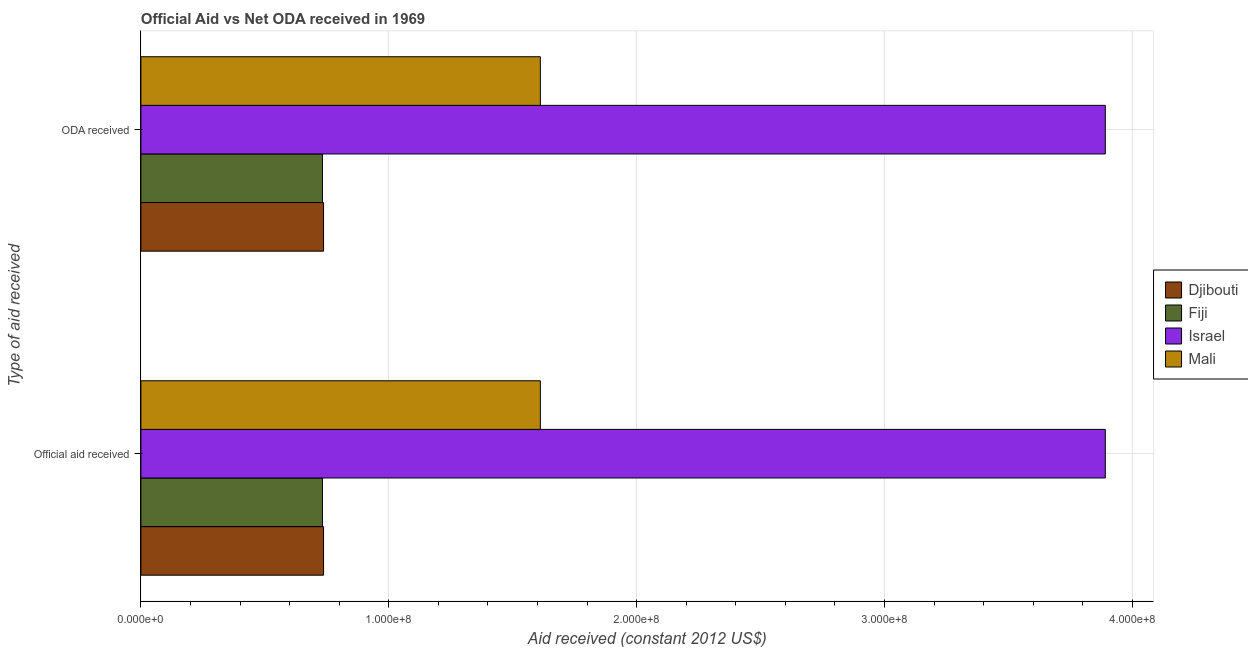How many different coloured bars are there?
Your answer should be very brief. 4. How many groups of bars are there?
Your answer should be compact. 2. How many bars are there on the 2nd tick from the top?
Your response must be concise. 4. How many bars are there on the 1st tick from the bottom?
Provide a succinct answer. 4. What is the label of the 1st group of bars from the top?
Provide a succinct answer. ODA received. What is the oda received in Israel?
Offer a very short reply. 3.89e+08. Across all countries, what is the maximum official aid received?
Ensure brevity in your answer.  3.89e+08. Across all countries, what is the minimum oda received?
Ensure brevity in your answer.  7.32e+07. In which country was the official aid received maximum?
Make the answer very short. Israel. In which country was the official aid received minimum?
Ensure brevity in your answer.  Fiji. What is the total official aid received in the graph?
Give a very brief answer. 6.97e+08. What is the difference between the official aid received in Israel and that in Djibouti?
Your answer should be compact. 3.15e+08. What is the difference between the oda received in Mali and the official aid received in Fiji?
Your answer should be compact. 8.79e+07. What is the average oda received per country?
Ensure brevity in your answer.  1.74e+08. What is the difference between the official aid received and oda received in Israel?
Provide a succinct answer. 0. What is the ratio of the official aid received in Mali to that in Israel?
Your answer should be very brief. 0.41. What does the 1st bar from the top in ODA received represents?
Provide a succinct answer. Mali. What does the 3rd bar from the bottom in ODA received represents?
Your answer should be very brief. Israel. How many bars are there?
Offer a very short reply. 8. Are all the bars in the graph horizontal?
Give a very brief answer. Yes. How many countries are there in the graph?
Provide a short and direct response. 4. Are the values on the major ticks of X-axis written in scientific E-notation?
Make the answer very short. Yes. Does the graph contain grids?
Give a very brief answer. Yes. Where does the legend appear in the graph?
Offer a terse response. Center right. How many legend labels are there?
Offer a very short reply. 4. How are the legend labels stacked?
Ensure brevity in your answer.  Vertical. What is the title of the graph?
Keep it short and to the point. Official Aid vs Net ODA received in 1969 . Does "Bhutan" appear as one of the legend labels in the graph?
Your response must be concise. No. What is the label or title of the X-axis?
Keep it short and to the point. Aid received (constant 2012 US$). What is the label or title of the Y-axis?
Provide a succinct answer. Type of aid received. What is the Aid received (constant 2012 US$) in Djibouti in Official aid received?
Offer a very short reply. 7.37e+07. What is the Aid received (constant 2012 US$) of Fiji in Official aid received?
Offer a terse response. 7.32e+07. What is the Aid received (constant 2012 US$) in Israel in Official aid received?
Your response must be concise. 3.89e+08. What is the Aid received (constant 2012 US$) in Mali in Official aid received?
Provide a short and direct response. 1.61e+08. What is the Aid received (constant 2012 US$) of Djibouti in ODA received?
Ensure brevity in your answer.  7.37e+07. What is the Aid received (constant 2012 US$) of Fiji in ODA received?
Keep it short and to the point. 7.32e+07. What is the Aid received (constant 2012 US$) of Israel in ODA received?
Your answer should be compact. 3.89e+08. What is the Aid received (constant 2012 US$) in Mali in ODA received?
Ensure brevity in your answer.  1.61e+08. Across all Type of aid received, what is the maximum Aid received (constant 2012 US$) of Djibouti?
Your answer should be compact. 7.37e+07. Across all Type of aid received, what is the maximum Aid received (constant 2012 US$) of Fiji?
Your answer should be very brief. 7.32e+07. Across all Type of aid received, what is the maximum Aid received (constant 2012 US$) in Israel?
Offer a very short reply. 3.89e+08. Across all Type of aid received, what is the maximum Aid received (constant 2012 US$) of Mali?
Make the answer very short. 1.61e+08. Across all Type of aid received, what is the minimum Aid received (constant 2012 US$) of Djibouti?
Your answer should be very brief. 7.37e+07. Across all Type of aid received, what is the minimum Aid received (constant 2012 US$) of Fiji?
Ensure brevity in your answer.  7.32e+07. Across all Type of aid received, what is the minimum Aid received (constant 2012 US$) of Israel?
Ensure brevity in your answer.  3.89e+08. Across all Type of aid received, what is the minimum Aid received (constant 2012 US$) in Mali?
Give a very brief answer. 1.61e+08. What is the total Aid received (constant 2012 US$) in Djibouti in the graph?
Keep it short and to the point. 1.47e+08. What is the total Aid received (constant 2012 US$) in Fiji in the graph?
Make the answer very short. 1.46e+08. What is the total Aid received (constant 2012 US$) of Israel in the graph?
Give a very brief answer. 7.78e+08. What is the total Aid received (constant 2012 US$) of Mali in the graph?
Make the answer very short. 3.22e+08. What is the difference between the Aid received (constant 2012 US$) of Fiji in Official aid received and that in ODA received?
Offer a terse response. 0. What is the difference between the Aid received (constant 2012 US$) in Israel in Official aid received and that in ODA received?
Provide a short and direct response. 0. What is the difference between the Aid received (constant 2012 US$) in Mali in Official aid received and that in ODA received?
Ensure brevity in your answer.  0. What is the difference between the Aid received (constant 2012 US$) of Djibouti in Official aid received and the Aid received (constant 2012 US$) of Israel in ODA received?
Offer a terse response. -3.15e+08. What is the difference between the Aid received (constant 2012 US$) of Djibouti in Official aid received and the Aid received (constant 2012 US$) of Mali in ODA received?
Make the answer very short. -8.74e+07. What is the difference between the Aid received (constant 2012 US$) in Fiji in Official aid received and the Aid received (constant 2012 US$) in Israel in ODA received?
Ensure brevity in your answer.  -3.16e+08. What is the difference between the Aid received (constant 2012 US$) of Fiji in Official aid received and the Aid received (constant 2012 US$) of Mali in ODA received?
Your response must be concise. -8.79e+07. What is the difference between the Aid received (constant 2012 US$) of Israel in Official aid received and the Aid received (constant 2012 US$) of Mali in ODA received?
Keep it short and to the point. 2.28e+08. What is the average Aid received (constant 2012 US$) in Djibouti per Type of aid received?
Offer a terse response. 7.37e+07. What is the average Aid received (constant 2012 US$) of Fiji per Type of aid received?
Offer a terse response. 7.32e+07. What is the average Aid received (constant 2012 US$) of Israel per Type of aid received?
Provide a short and direct response. 3.89e+08. What is the average Aid received (constant 2012 US$) in Mali per Type of aid received?
Your answer should be very brief. 1.61e+08. What is the difference between the Aid received (constant 2012 US$) in Djibouti and Aid received (constant 2012 US$) in Fiji in Official aid received?
Your answer should be very brief. 4.60e+05. What is the difference between the Aid received (constant 2012 US$) in Djibouti and Aid received (constant 2012 US$) in Israel in Official aid received?
Provide a succinct answer. -3.15e+08. What is the difference between the Aid received (constant 2012 US$) in Djibouti and Aid received (constant 2012 US$) in Mali in Official aid received?
Offer a terse response. -8.74e+07. What is the difference between the Aid received (constant 2012 US$) of Fiji and Aid received (constant 2012 US$) of Israel in Official aid received?
Offer a terse response. -3.16e+08. What is the difference between the Aid received (constant 2012 US$) in Fiji and Aid received (constant 2012 US$) in Mali in Official aid received?
Ensure brevity in your answer.  -8.79e+07. What is the difference between the Aid received (constant 2012 US$) in Israel and Aid received (constant 2012 US$) in Mali in Official aid received?
Make the answer very short. 2.28e+08. What is the difference between the Aid received (constant 2012 US$) in Djibouti and Aid received (constant 2012 US$) in Fiji in ODA received?
Make the answer very short. 4.60e+05. What is the difference between the Aid received (constant 2012 US$) in Djibouti and Aid received (constant 2012 US$) in Israel in ODA received?
Your answer should be compact. -3.15e+08. What is the difference between the Aid received (constant 2012 US$) in Djibouti and Aid received (constant 2012 US$) in Mali in ODA received?
Offer a very short reply. -8.74e+07. What is the difference between the Aid received (constant 2012 US$) of Fiji and Aid received (constant 2012 US$) of Israel in ODA received?
Offer a very short reply. -3.16e+08. What is the difference between the Aid received (constant 2012 US$) in Fiji and Aid received (constant 2012 US$) in Mali in ODA received?
Offer a terse response. -8.79e+07. What is the difference between the Aid received (constant 2012 US$) of Israel and Aid received (constant 2012 US$) of Mali in ODA received?
Ensure brevity in your answer.  2.28e+08. What is the ratio of the Aid received (constant 2012 US$) in Mali in Official aid received to that in ODA received?
Offer a terse response. 1. What is the difference between the highest and the second highest Aid received (constant 2012 US$) in Djibouti?
Your answer should be compact. 0. What is the difference between the highest and the second highest Aid received (constant 2012 US$) of Israel?
Give a very brief answer. 0. 